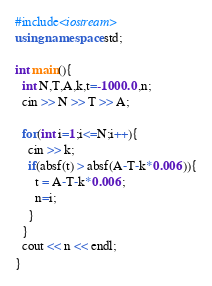Convert code to text. <code><loc_0><loc_0><loc_500><loc_500><_C++_>#include<iostream>
using namespace std;
 
int main(){
  int N,T,A,k,t=-1000.0,n;
  cin >> N >> T >> A;
  
  for(int i=1;i<=N;i++){
    cin >> k;
    if(absf(t) > absf(A-T-k*0.006)){
      t = A-T-k*0.006;
      n=i;
    }
  }
  cout << n << endl;
}</code> 